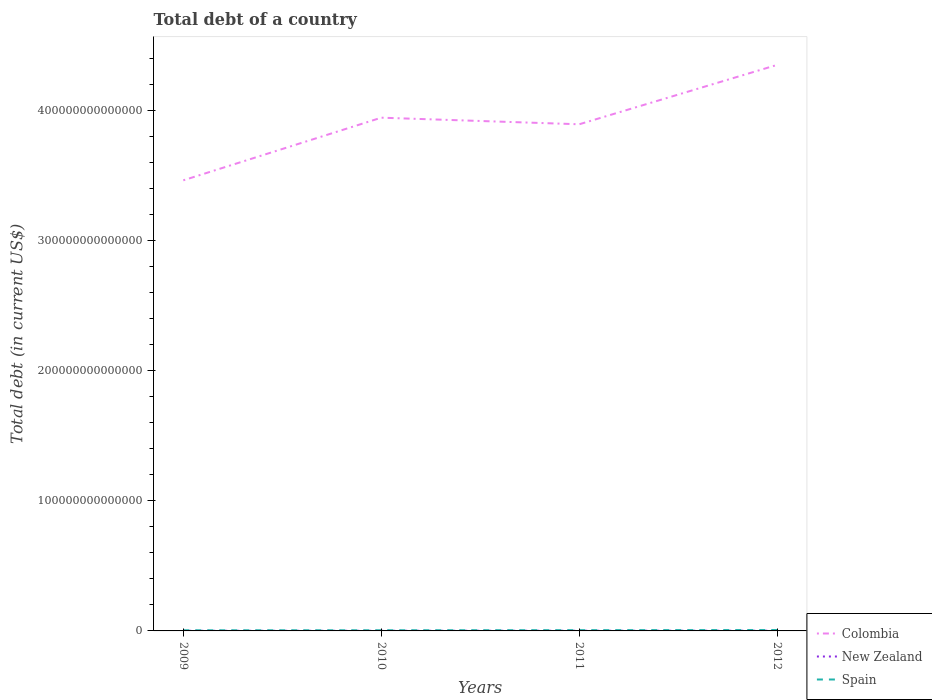How many different coloured lines are there?
Offer a terse response. 3. Across all years, what is the maximum debt in Colombia?
Your answer should be compact. 3.46e+14. What is the total debt in New Zealand in the graph?
Ensure brevity in your answer.  -8.43e+09. What is the difference between the highest and the second highest debt in Spain?
Offer a very short reply. 2.04e+11. What is the difference between the highest and the lowest debt in Colombia?
Ensure brevity in your answer.  2. Is the debt in Spain strictly greater than the debt in New Zealand over the years?
Keep it short and to the point. No. How many lines are there?
Offer a very short reply. 3. How many years are there in the graph?
Provide a succinct answer. 4. What is the difference between two consecutive major ticks on the Y-axis?
Offer a terse response. 1.00e+14. Are the values on the major ticks of Y-axis written in scientific E-notation?
Ensure brevity in your answer.  No. How are the legend labels stacked?
Offer a terse response. Vertical. What is the title of the graph?
Provide a short and direct response. Total debt of a country. What is the label or title of the Y-axis?
Make the answer very short. Total debt (in current US$). What is the Total debt (in current US$) of Colombia in 2009?
Offer a very short reply. 3.46e+14. What is the Total debt (in current US$) in New Zealand in 2009?
Your answer should be compact. 9.17e+1. What is the Total debt (in current US$) in Spain in 2009?
Keep it short and to the point. 4.92e+11. What is the Total debt (in current US$) in Colombia in 2010?
Keep it short and to the point. 3.94e+14. What is the Total debt (in current US$) of New Zealand in 2010?
Provide a succinct answer. 1.00e+11. What is the Total debt (in current US$) in Spain in 2010?
Ensure brevity in your answer.  5.09e+11. What is the Total debt (in current US$) of Colombia in 2011?
Give a very brief answer. 3.89e+14. What is the Total debt (in current US$) in New Zealand in 2011?
Your answer should be compact. 1.33e+11. What is the Total debt (in current US$) in Spain in 2011?
Offer a very short reply. 5.87e+11. What is the Total debt (in current US$) of Colombia in 2012?
Your answer should be compact. 4.35e+14. What is the Total debt (in current US$) in New Zealand in 2012?
Provide a succinct answer. 1.46e+11. What is the Total debt (in current US$) in Spain in 2012?
Your answer should be very brief. 6.96e+11. Across all years, what is the maximum Total debt (in current US$) of Colombia?
Your response must be concise. 4.35e+14. Across all years, what is the maximum Total debt (in current US$) of New Zealand?
Make the answer very short. 1.46e+11. Across all years, what is the maximum Total debt (in current US$) of Spain?
Offer a very short reply. 6.96e+11. Across all years, what is the minimum Total debt (in current US$) of Colombia?
Keep it short and to the point. 3.46e+14. Across all years, what is the minimum Total debt (in current US$) of New Zealand?
Ensure brevity in your answer.  9.17e+1. Across all years, what is the minimum Total debt (in current US$) in Spain?
Your response must be concise. 4.92e+11. What is the total Total debt (in current US$) in Colombia in the graph?
Your response must be concise. 1.56e+15. What is the total Total debt (in current US$) in New Zealand in the graph?
Provide a short and direct response. 4.71e+11. What is the total Total debt (in current US$) in Spain in the graph?
Offer a terse response. 2.28e+12. What is the difference between the Total debt (in current US$) of Colombia in 2009 and that in 2010?
Keep it short and to the point. -4.81e+13. What is the difference between the Total debt (in current US$) of New Zealand in 2009 and that in 2010?
Provide a short and direct response. -8.43e+09. What is the difference between the Total debt (in current US$) of Spain in 2009 and that in 2010?
Your answer should be compact. -1.75e+1. What is the difference between the Total debt (in current US$) of Colombia in 2009 and that in 2011?
Your answer should be compact. -4.30e+13. What is the difference between the Total debt (in current US$) of New Zealand in 2009 and that in 2011?
Make the answer very short. -4.18e+1. What is the difference between the Total debt (in current US$) of Spain in 2009 and that in 2011?
Offer a terse response. -9.54e+1. What is the difference between the Total debt (in current US$) in Colombia in 2009 and that in 2012?
Your response must be concise. -8.87e+13. What is the difference between the Total debt (in current US$) in New Zealand in 2009 and that in 2012?
Your response must be concise. -5.44e+1. What is the difference between the Total debt (in current US$) in Spain in 2009 and that in 2012?
Make the answer very short. -2.04e+11. What is the difference between the Total debt (in current US$) in Colombia in 2010 and that in 2011?
Your answer should be very brief. 5.07e+12. What is the difference between the Total debt (in current US$) of New Zealand in 2010 and that in 2011?
Ensure brevity in your answer.  -3.33e+1. What is the difference between the Total debt (in current US$) in Spain in 2010 and that in 2011?
Keep it short and to the point. -7.79e+1. What is the difference between the Total debt (in current US$) of Colombia in 2010 and that in 2012?
Ensure brevity in your answer.  -4.06e+13. What is the difference between the Total debt (in current US$) in New Zealand in 2010 and that in 2012?
Your answer should be very brief. -4.59e+1. What is the difference between the Total debt (in current US$) in Spain in 2010 and that in 2012?
Provide a succinct answer. -1.86e+11. What is the difference between the Total debt (in current US$) in Colombia in 2011 and that in 2012?
Your answer should be compact. -4.56e+13. What is the difference between the Total debt (in current US$) of New Zealand in 2011 and that in 2012?
Provide a short and direct response. -1.26e+1. What is the difference between the Total debt (in current US$) in Spain in 2011 and that in 2012?
Provide a succinct answer. -1.09e+11. What is the difference between the Total debt (in current US$) in Colombia in 2009 and the Total debt (in current US$) in New Zealand in 2010?
Give a very brief answer. 3.46e+14. What is the difference between the Total debt (in current US$) in Colombia in 2009 and the Total debt (in current US$) in Spain in 2010?
Make the answer very short. 3.46e+14. What is the difference between the Total debt (in current US$) in New Zealand in 2009 and the Total debt (in current US$) in Spain in 2010?
Keep it short and to the point. -4.17e+11. What is the difference between the Total debt (in current US$) in Colombia in 2009 and the Total debt (in current US$) in New Zealand in 2011?
Your answer should be compact. 3.46e+14. What is the difference between the Total debt (in current US$) of Colombia in 2009 and the Total debt (in current US$) of Spain in 2011?
Ensure brevity in your answer.  3.45e+14. What is the difference between the Total debt (in current US$) in New Zealand in 2009 and the Total debt (in current US$) in Spain in 2011?
Offer a terse response. -4.95e+11. What is the difference between the Total debt (in current US$) of Colombia in 2009 and the Total debt (in current US$) of New Zealand in 2012?
Your answer should be very brief. 3.46e+14. What is the difference between the Total debt (in current US$) of Colombia in 2009 and the Total debt (in current US$) of Spain in 2012?
Offer a terse response. 3.45e+14. What is the difference between the Total debt (in current US$) of New Zealand in 2009 and the Total debt (in current US$) of Spain in 2012?
Keep it short and to the point. -6.04e+11. What is the difference between the Total debt (in current US$) in Colombia in 2010 and the Total debt (in current US$) in New Zealand in 2011?
Offer a very short reply. 3.94e+14. What is the difference between the Total debt (in current US$) of Colombia in 2010 and the Total debt (in current US$) of Spain in 2011?
Offer a very short reply. 3.94e+14. What is the difference between the Total debt (in current US$) of New Zealand in 2010 and the Total debt (in current US$) of Spain in 2011?
Your response must be concise. -4.87e+11. What is the difference between the Total debt (in current US$) in Colombia in 2010 and the Total debt (in current US$) in New Zealand in 2012?
Provide a succinct answer. 3.94e+14. What is the difference between the Total debt (in current US$) of Colombia in 2010 and the Total debt (in current US$) of Spain in 2012?
Keep it short and to the point. 3.93e+14. What is the difference between the Total debt (in current US$) of New Zealand in 2010 and the Total debt (in current US$) of Spain in 2012?
Offer a terse response. -5.95e+11. What is the difference between the Total debt (in current US$) in Colombia in 2011 and the Total debt (in current US$) in New Zealand in 2012?
Offer a very short reply. 3.89e+14. What is the difference between the Total debt (in current US$) in Colombia in 2011 and the Total debt (in current US$) in Spain in 2012?
Ensure brevity in your answer.  3.88e+14. What is the difference between the Total debt (in current US$) in New Zealand in 2011 and the Total debt (in current US$) in Spain in 2012?
Your response must be concise. -5.62e+11. What is the average Total debt (in current US$) of Colombia per year?
Make the answer very short. 3.91e+14. What is the average Total debt (in current US$) in New Zealand per year?
Your answer should be very brief. 1.18e+11. What is the average Total debt (in current US$) of Spain per year?
Your answer should be compact. 5.71e+11. In the year 2009, what is the difference between the Total debt (in current US$) of Colombia and Total debt (in current US$) of New Zealand?
Provide a short and direct response. 3.46e+14. In the year 2009, what is the difference between the Total debt (in current US$) of Colombia and Total debt (in current US$) of Spain?
Provide a short and direct response. 3.46e+14. In the year 2009, what is the difference between the Total debt (in current US$) in New Zealand and Total debt (in current US$) in Spain?
Make the answer very short. -4.00e+11. In the year 2010, what is the difference between the Total debt (in current US$) of Colombia and Total debt (in current US$) of New Zealand?
Offer a very short reply. 3.94e+14. In the year 2010, what is the difference between the Total debt (in current US$) in Colombia and Total debt (in current US$) in Spain?
Your response must be concise. 3.94e+14. In the year 2010, what is the difference between the Total debt (in current US$) of New Zealand and Total debt (in current US$) of Spain?
Your response must be concise. -4.09e+11. In the year 2011, what is the difference between the Total debt (in current US$) in Colombia and Total debt (in current US$) in New Zealand?
Offer a very short reply. 3.89e+14. In the year 2011, what is the difference between the Total debt (in current US$) in Colombia and Total debt (in current US$) in Spain?
Ensure brevity in your answer.  3.89e+14. In the year 2011, what is the difference between the Total debt (in current US$) in New Zealand and Total debt (in current US$) in Spain?
Offer a very short reply. -4.54e+11. In the year 2012, what is the difference between the Total debt (in current US$) of Colombia and Total debt (in current US$) of New Zealand?
Your answer should be very brief. 4.35e+14. In the year 2012, what is the difference between the Total debt (in current US$) in Colombia and Total debt (in current US$) in Spain?
Provide a short and direct response. 4.34e+14. In the year 2012, what is the difference between the Total debt (in current US$) in New Zealand and Total debt (in current US$) in Spain?
Keep it short and to the point. -5.49e+11. What is the ratio of the Total debt (in current US$) in Colombia in 2009 to that in 2010?
Your answer should be compact. 0.88. What is the ratio of the Total debt (in current US$) of New Zealand in 2009 to that in 2010?
Keep it short and to the point. 0.92. What is the ratio of the Total debt (in current US$) of Spain in 2009 to that in 2010?
Provide a succinct answer. 0.97. What is the ratio of the Total debt (in current US$) in Colombia in 2009 to that in 2011?
Your response must be concise. 0.89. What is the ratio of the Total debt (in current US$) in New Zealand in 2009 to that in 2011?
Your answer should be very brief. 0.69. What is the ratio of the Total debt (in current US$) in Spain in 2009 to that in 2011?
Your answer should be very brief. 0.84. What is the ratio of the Total debt (in current US$) of Colombia in 2009 to that in 2012?
Keep it short and to the point. 0.8. What is the ratio of the Total debt (in current US$) in New Zealand in 2009 to that in 2012?
Offer a terse response. 0.63. What is the ratio of the Total debt (in current US$) of Spain in 2009 to that in 2012?
Keep it short and to the point. 0.71. What is the ratio of the Total debt (in current US$) of Colombia in 2010 to that in 2011?
Your answer should be very brief. 1.01. What is the ratio of the Total debt (in current US$) of New Zealand in 2010 to that in 2011?
Ensure brevity in your answer.  0.75. What is the ratio of the Total debt (in current US$) in Spain in 2010 to that in 2011?
Offer a terse response. 0.87. What is the ratio of the Total debt (in current US$) in Colombia in 2010 to that in 2012?
Give a very brief answer. 0.91. What is the ratio of the Total debt (in current US$) of New Zealand in 2010 to that in 2012?
Provide a short and direct response. 0.69. What is the ratio of the Total debt (in current US$) of Spain in 2010 to that in 2012?
Your answer should be very brief. 0.73. What is the ratio of the Total debt (in current US$) in Colombia in 2011 to that in 2012?
Provide a short and direct response. 0.9. What is the ratio of the Total debt (in current US$) in New Zealand in 2011 to that in 2012?
Ensure brevity in your answer.  0.91. What is the ratio of the Total debt (in current US$) in Spain in 2011 to that in 2012?
Keep it short and to the point. 0.84. What is the difference between the highest and the second highest Total debt (in current US$) of Colombia?
Offer a very short reply. 4.06e+13. What is the difference between the highest and the second highest Total debt (in current US$) of New Zealand?
Provide a succinct answer. 1.26e+1. What is the difference between the highest and the second highest Total debt (in current US$) of Spain?
Offer a very short reply. 1.09e+11. What is the difference between the highest and the lowest Total debt (in current US$) in Colombia?
Ensure brevity in your answer.  8.87e+13. What is the difference between the highest and the lowest Total debt (in current US$) of New Zealand?
Ensure brevity in your answer.  5.44e+1. What is the difference between the highest and the lowest Total debt (in current US$) of Spain?
Provide a succinct answer. 2.04e+11. 